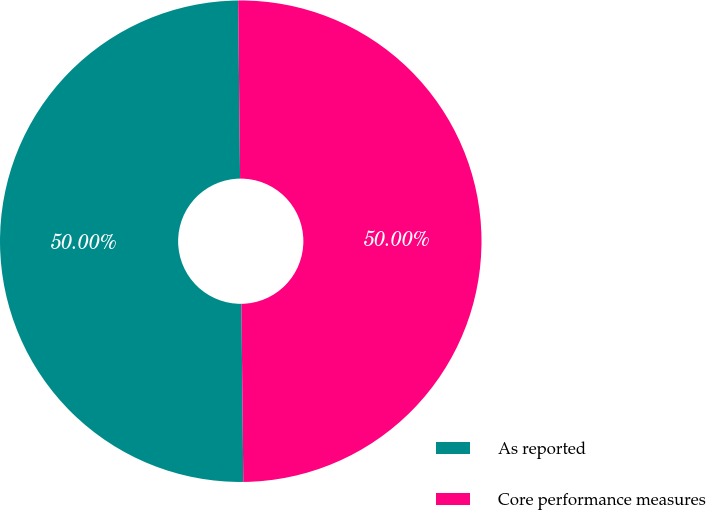Convert chart. <chart><loc_0><loc_0><loc_500><loc_500><pie_chart><fcel>As reported<fcel>Core performance measures<nl><fcel>50.0%<fcel>50.0%<nl></chart> 